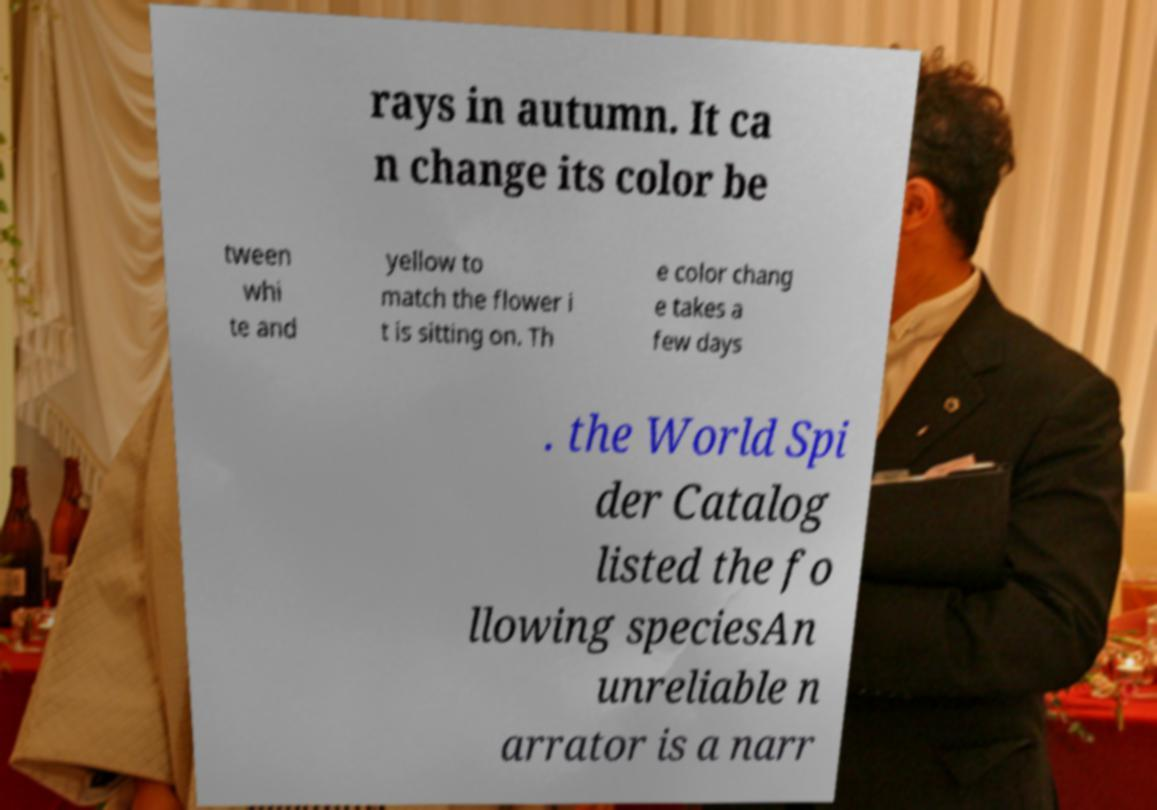There's text embedded in this image that I need extracted. Can you transcribe it verbatim? rays in autumn. It ca n change its color be tween whi te and yellow to match the flower i t is sitting on. Th e color chang e takes a few days . the World Spi der Catalog listed the fo llowing speciesAn unreliable n arrator is a narr 